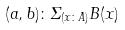Convert formula to latex. <formula><loc_0><loc_0><loc_500><loc_500>( a , b ) \colon \Sigma _ { ( x \colon A ) } B ( x )</formula> 